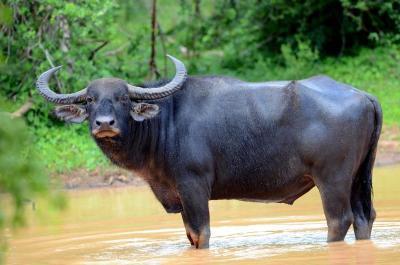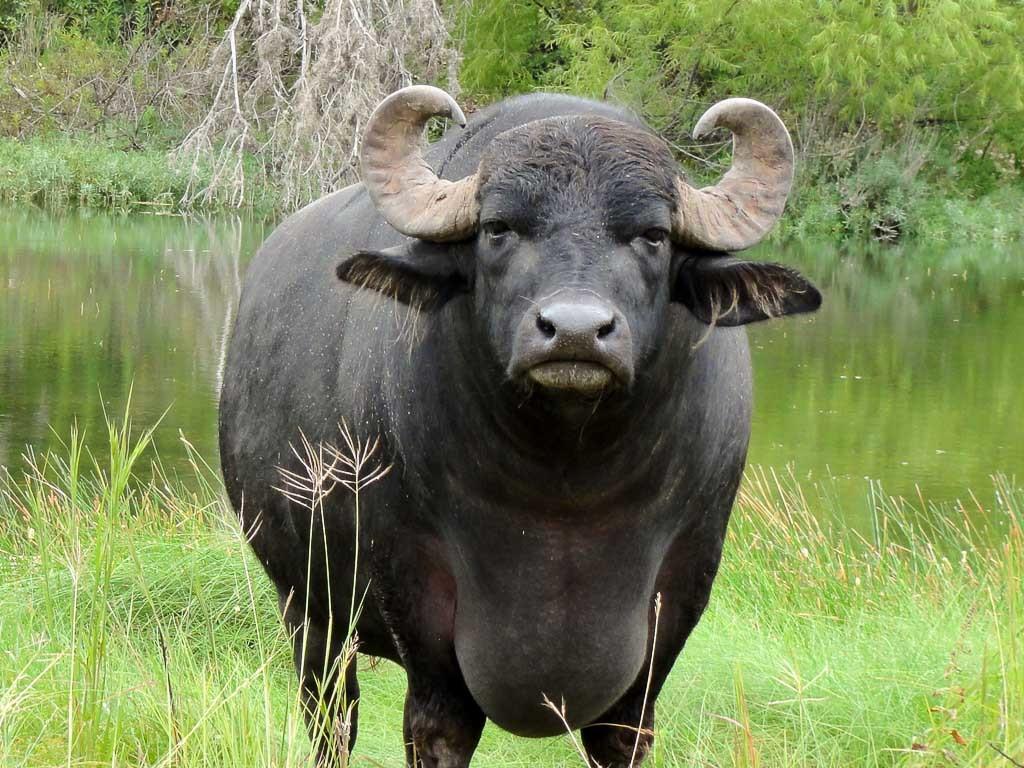The first image is the image on the left, the second image is the image on the right. Analyze the images presented: Is the assertion "There is an animal that is not an ox in at least one image." valid? Answer yes or no. No. 